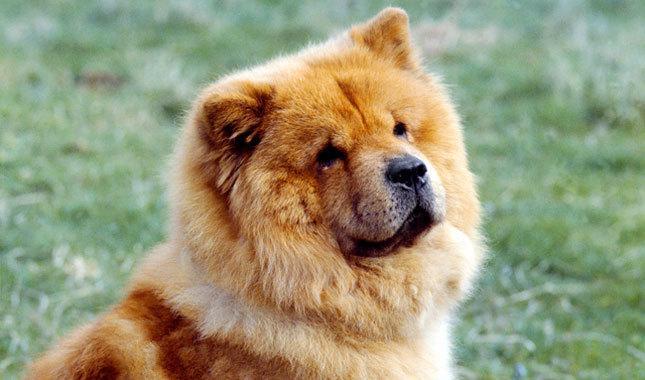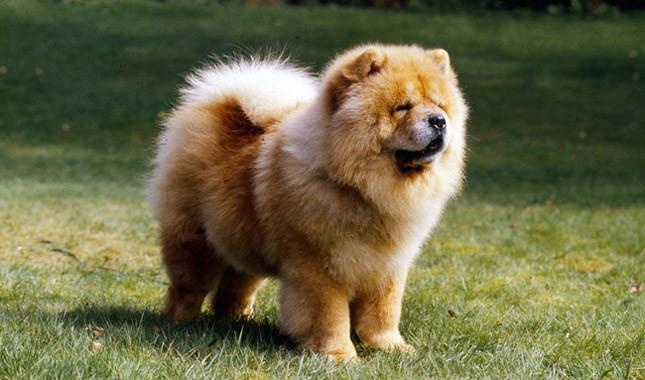The first image is the image on the left, the second image is the image on the right. Examine the images to the left and right. Is the description "The dog in the image on the right is standing on all fours in the grass." accurate? Answer yes or no. Yes. The first image is the image on the left, the second image is the image on the right. For the images shown, is this caption "All images show exactly one chow dog standing on all fours." true? Answer yes or no. No. 